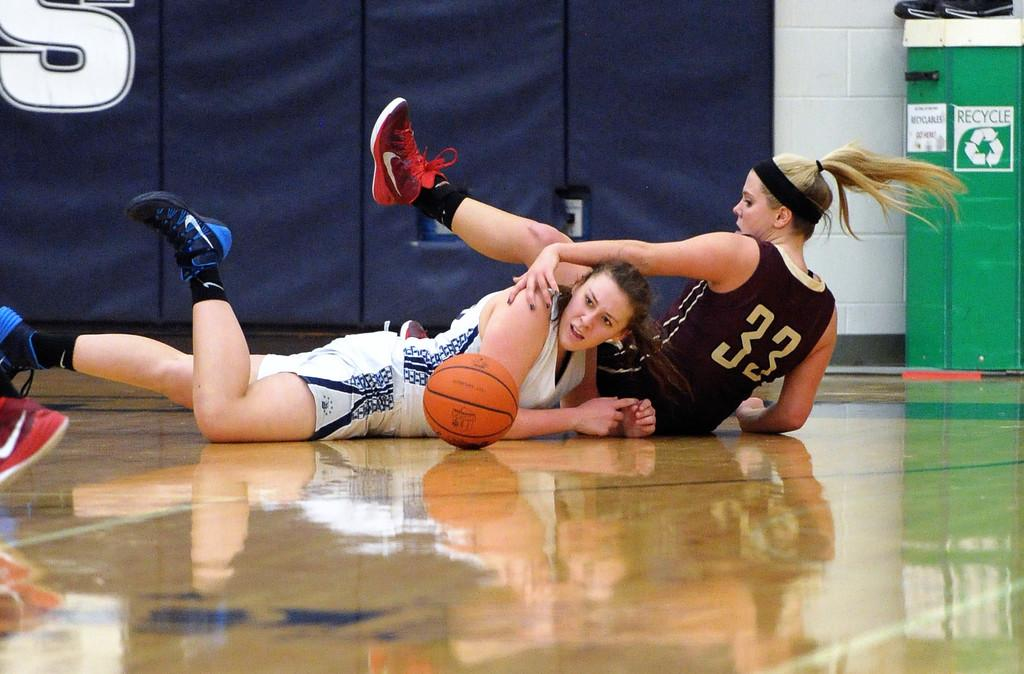<image>
Provide a brief description of the given image. Two basketball players on the ground with a Recycle bin in the background. 